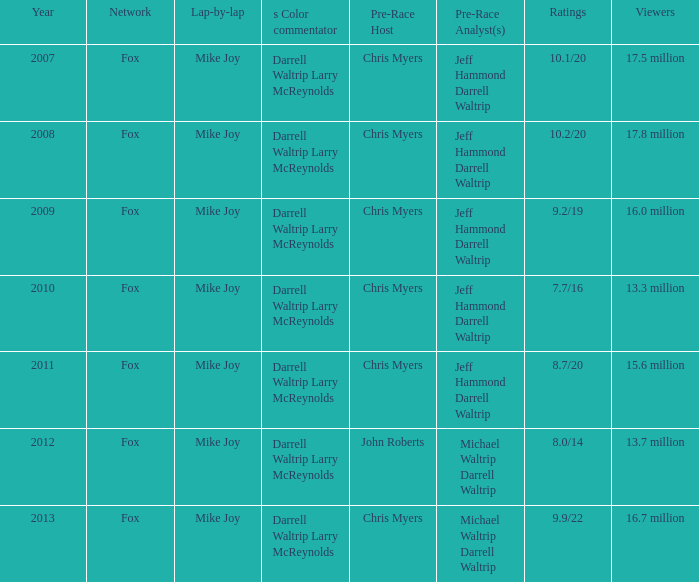What lap-by-lap includes chris myers as the pre-race host, a year exceeding 2008, and Mike Joy. 